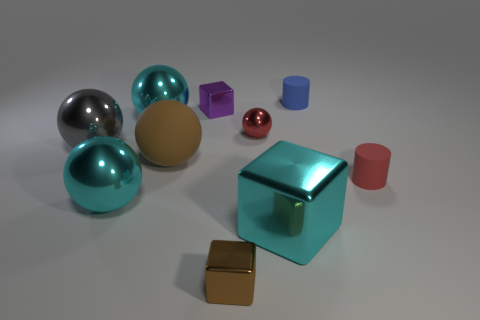There is a large cyan sphere that is in front of the brown object behind the brown cube; are there any tiny brown metal blocks in front of it?
Offer a terse response. Yes. Is there anything else that has the same size as the brown ball?
Give a very brief answer. Yes. There is a blue thing; is its shape the same as the brown object behind the small red rubber object?
Make the answer very short. No. The metal sphere that is behind the metallic sphere to the right of the small object that is in front of the red cylinder is what color?
Offer a terse response. Cyan. What number of things are either cyan shiny things right of the matte sphere or big cyan metal balls that are in front of the large gray metal ball?
Give a very brief answer. 2. What number of other objects are there of the same color as the big matte object?
Keep it short and to the point. 1. There is a tiny red thing that is to the left of the big shiny cube; is it the same shape as the purple metallic thing?
Give a very brief answer. No. Is the number of large cyan balls behind the red ball less than the number of small blue matte cylinders?
Offer a terse response. No. Are there any small red blocks that have the same material as the blue object?
Keep it short and to the point. No. What is the material of the blue cylinder that is the same size as the red metal ball?
Your answer should be very brief. Rubber. 